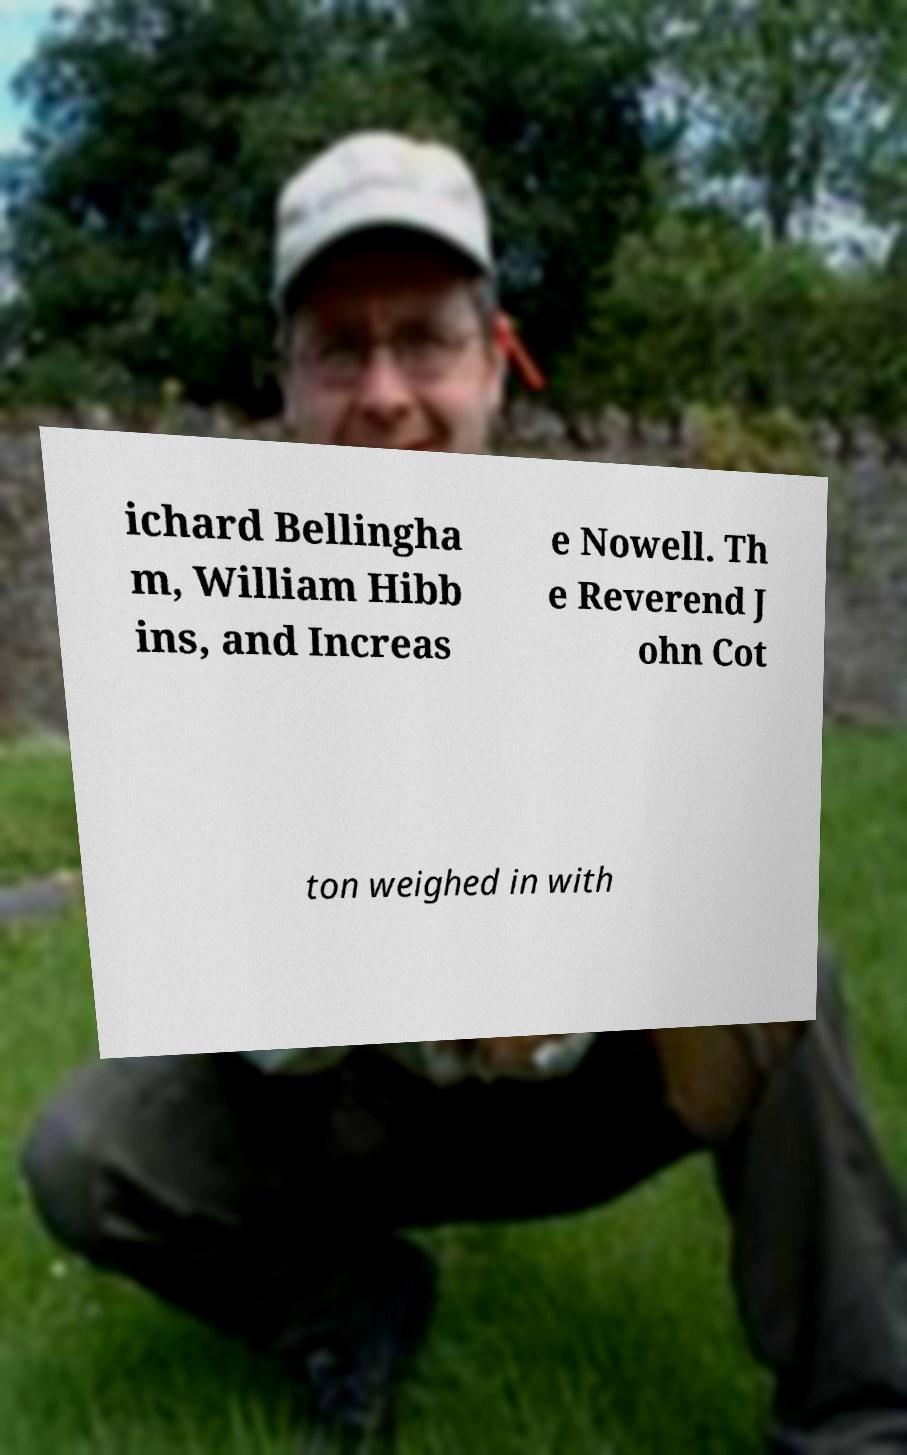Please identify and transcribe the text found in this image. ichard Bellingha m, William Hibb ins, and Increas e Nowell. Th e Reverend J ohn Cot ton weighed in with 